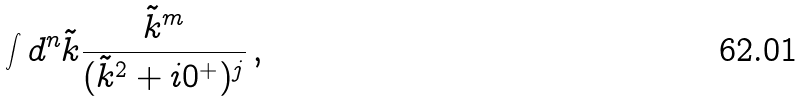Convert formula to latex. <formula><loc_0><loc_0><loc_500><loc_500>\int d ^ { n } \tilde { k } \frac { \tilde { k } ^ { m } } { ( \tilde { k } ^ { 2 } + i 0 ^ { + } ) ^ { j } } \, ,</formula> 